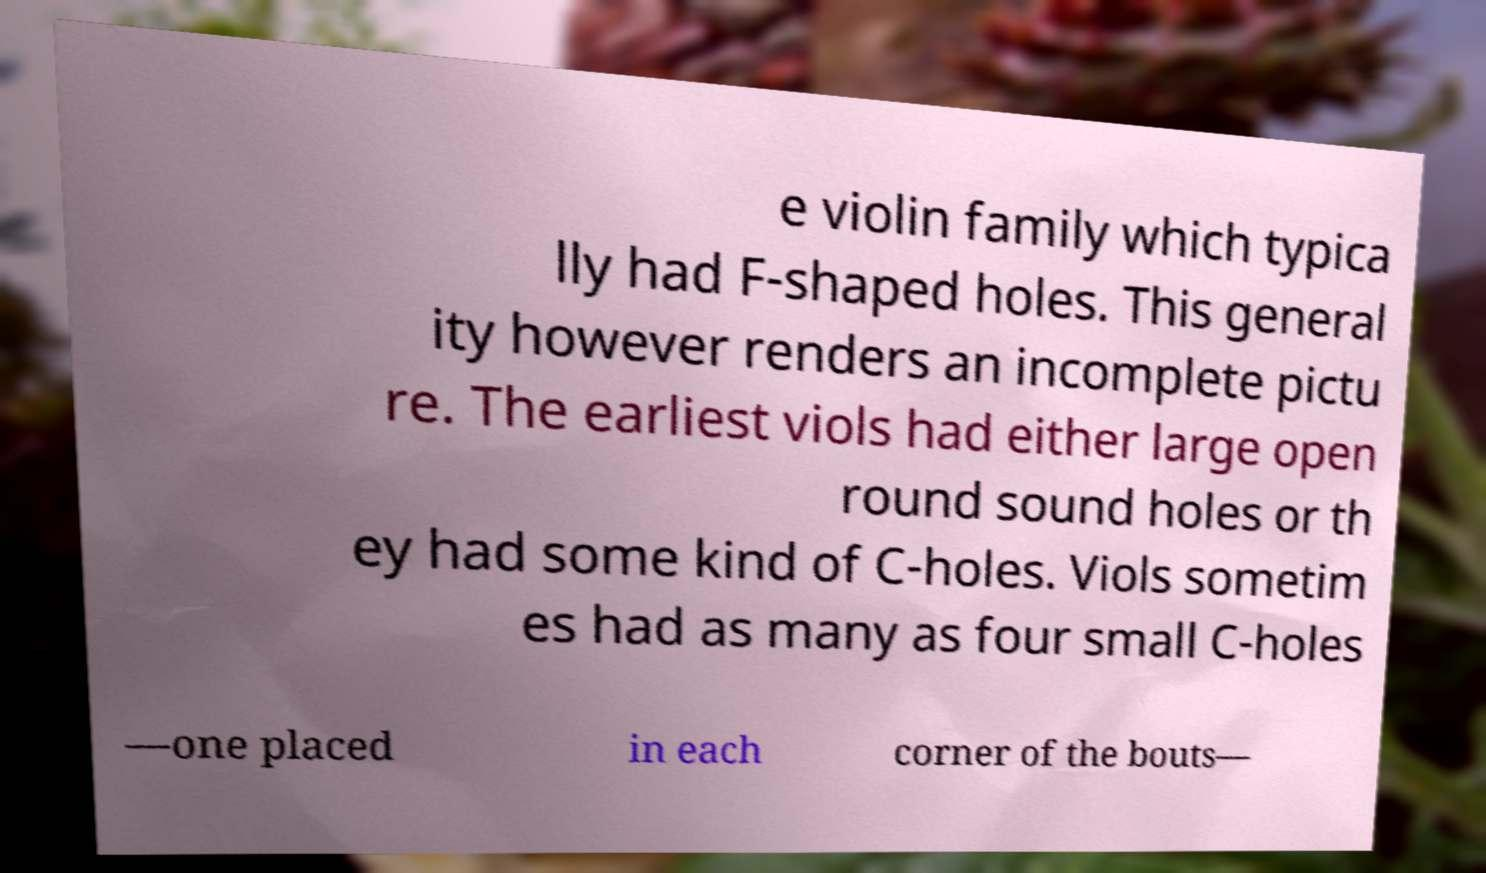Could you assist in decoding the text presented in this image and type it out clearly? e violin family which typica lly had F-shaped holes. This general ity however renders an incomplete pictu re. The earliest viols had either large open round sound holes or th ey had some kind of C-holes. Viols sometim es had as many as four small C-holes —one placed in each corner of the bouts— 